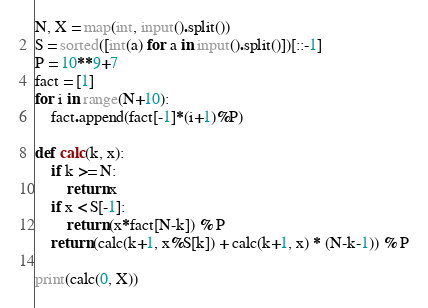<code> <loc_0><loc_0><loc_500><loc_500><_Python_>N, X = map(int, input().split())
S = sorted([int(a) for a in input().split()])[::-1]
P = 10**9+7
fact = [1]
for i in range(N+10):
    fact.append(fact[-1]*(i+1)%P)

def calc(k, x):
    if k >= N:
        return x
    if x < S[-1]:
        return (x*fact[N-k]) % P
    return (calc(k+1, x%S[k]) + calc(k+1, x) * (N-k-1)) % P

print(calc(0, X))
</code> 